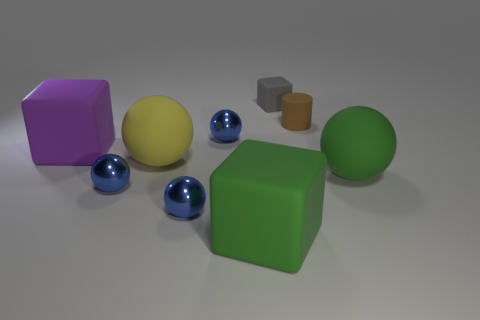There is a large rubber object behind the large yellow rubber thing; does it have the same shape as the green matte thing that is left of the big green sphere?
Your response must be concise. Yes. What is the color of the other large block that is the same material as the green block?
Your answer should be compact. Purple. Do the blue thing behind the large purple object and the matte cylinder behind the green block have the same size?
Offer a very short reply. Yes. There is a matte thing that is both behind the large green matte cube and in front of the yellow matte sphere; what is its shape?
Make the answer very short. Sphere. Is there a large green cube that has the same material as the large green ball?
Offer a very short reply. Yes. Do the small cube right of the yellow matte object and the large cube left of the big yellow sphere have the same material?
Give a very brief answer. Yes. Are there more small cyan metallic cylinders than large green balls?
Keep it short and to the point. No. What color is the big rubber object that is in front of the small blue metallic thing left of the big sphere that is left of the small brown cylinder?
Your response must be concise. Green. Does the rubber cube that is behind the big purple object have the same color as the large matte sphere that is behind the green rubber ball?
Your response must be concise. No. There is a yellow matte sphere that is on the right side of the big purple cube; what number of spheres are behind it?
Provide a short and direct response. 1. 